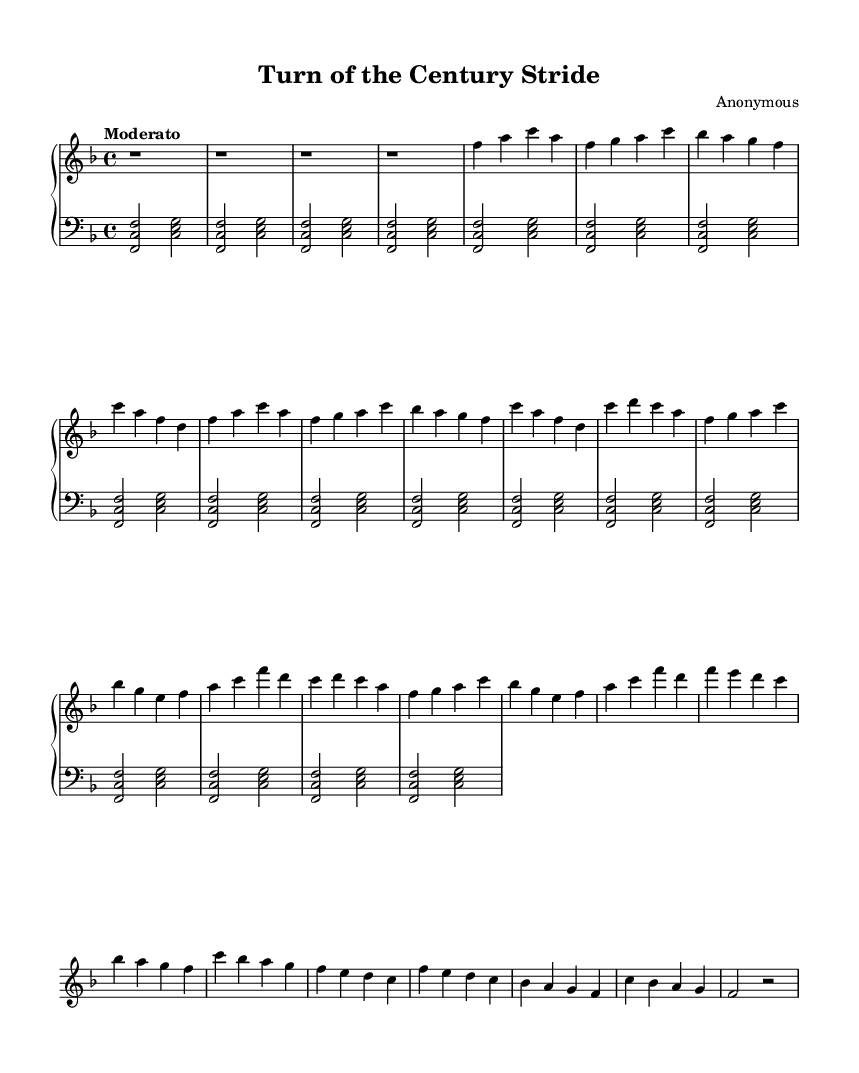What is the key signature of this music? The key signature shows one flat, which indicates that the piece is in F major.
Answer: F major What is the time signature of this music? The time signature indicates that there are four beats in each measure, as shown by the "4/4" notation.
Answer: 4/4 What is the tempo marking for this piece? The tempo marking indicates a "Moderato" pace, which suggests a moderate speed for the performance.
Answer: Moderato How many sections are there in the music? The sheet music includes three distinct sections labeled A, B, and C, indicating a total of three sections in the piece.
Answer: Three What is the highest pitch in the right-hand part? The highest pitch in the right-hand part is the note c' in the A and B sections, which is indicated as the highest note in those sections.
Answer: c' How does the left-hand part primarily differ from the right-hand part in terms of texture? The left-hand part utilizes block chords, creating a harmonic foundation, while the right-hand part contains a melodic line that is more intricate and rhythmically diverse.
Answer: Block chords What style of jazz does this piece exemplify? The combination of syncopated rhythms, ragged melodic lines, and the incorporation of elements from the late 19th-century popular music indicate that this piece exemplifies ragtime-inspired jazz.
Answer: Ragtime-inspired jazz 